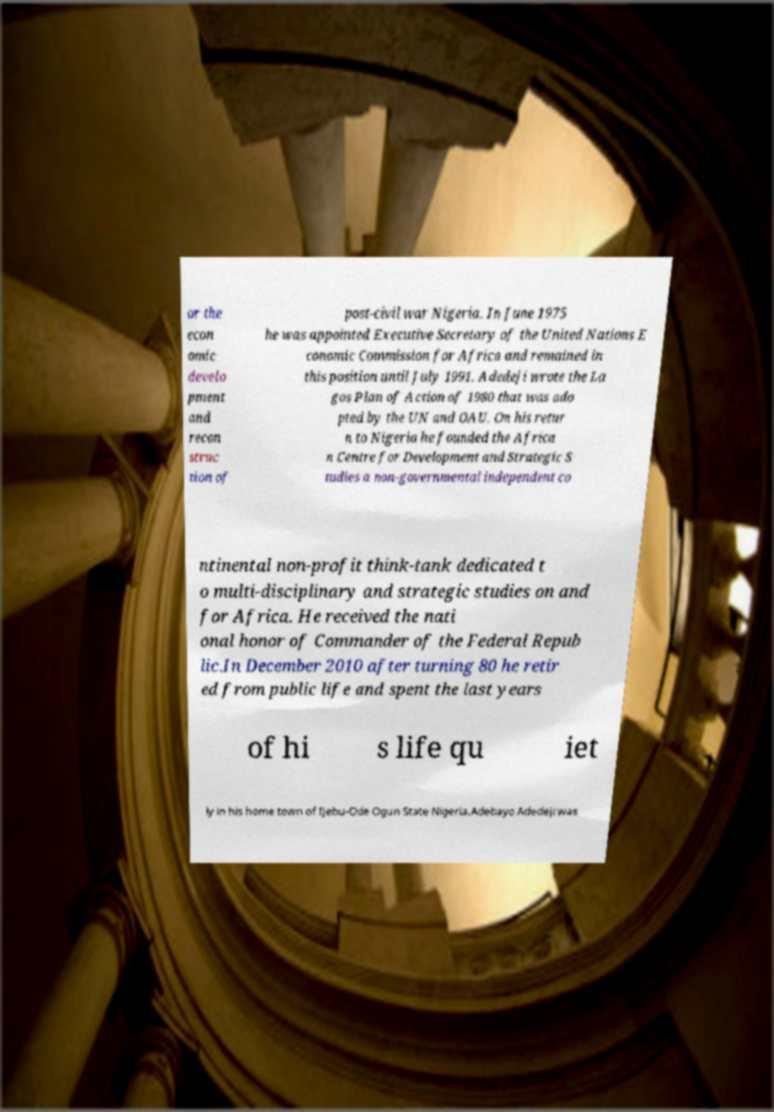Please read and relay the text visible in this image. What does it say? or the econ omic develo pment and recon struc tion of post-civil war Nigeria. In June 1975 he was appointed Executive Secretary of the United Nations E conomic Commission for Africa and remained in this position until July 1991. Adedeji wrote the La gos Plan of Action of 1980 that was ado pted by the UN and OAU. On his retur n to Nigeria he founded the Africa n Centre for Development and Strategic S tudies a non-governmental independent co ntinental non-profit think-tank dedicated t o multi-disciplinary and strategic studies on and for Africa. He received the nati onal honor of Commander of the Federal Repub lic.In December 2010 after turning 80 he retir ed from public life and spent the last years of hi s life qu iet ly in his home town of Ijebu-Ode Ogun State Nigeria.Adebayo Adedeji was 